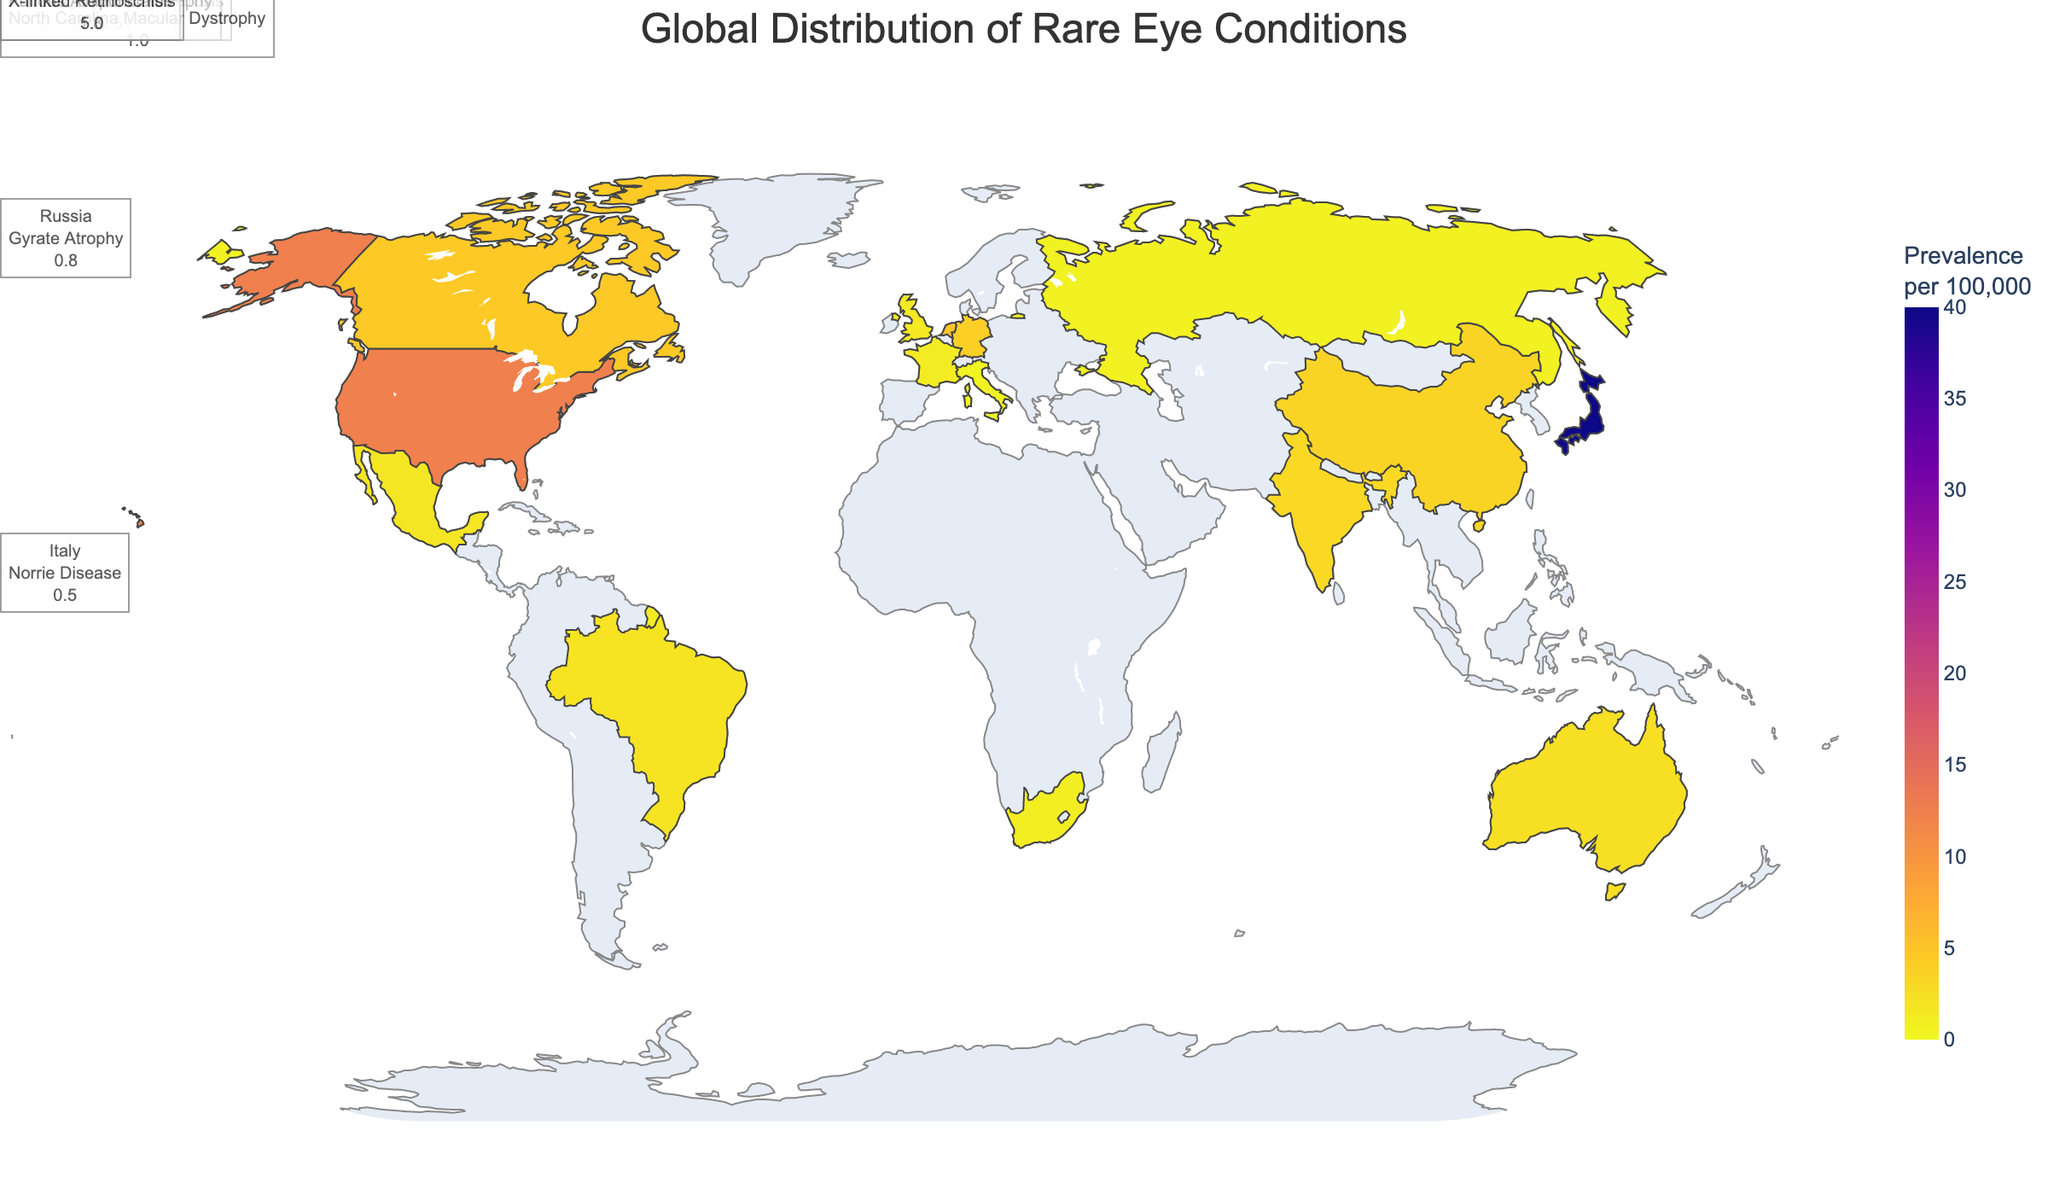What's the title of the figure? The title is usually found at the top of the figure. In this figure, it is "Global Distribution of Rare Eye Conditions".
Answer: Global Distribution of Rare Eye Conditions What's the prevalence rate of Retinitis Pigmentosa in Japan? The prevalence rate can be seen when you hover over Japan. It shows Retinitis Pigmentosa with a prevalence rate of 40.0 per 100,000.
Answer: 40.0 per 100,000 What condition is most prevalent in the United States and what is its prevalence rate? By looking at the hover data for the United States, it is clear that the condition is Stargardt Disease with a prevalence of 12.5 per 100,000.
Answer: Stargardt Disease, 12.5 per 100,000 How does the prevalence rate of Usher Syndrome in Germany compare to Fundus Albipunctatus in Mexico? By hovering over Germany, you can see that Usher Syndrome has a prevalence rate of 4.0 per 100,000. In Mexico, Fundus Albipunctatus has a prevalence rate of 1.8 per 100,000. Therefore, Usher Syndrome in Germany has a higher prevalence rate.
Answer: Higher in Germany What is the average prevalence rate of all the conditions listed? Sum all prevalence rates and divide by the number of countries (15 total): (12.5 + 40.0 + 4.0 + 2.0 + 3.0 + 1.5 + 2.5 + 4.5 + 1.2 + 3.5 + 0.5 + 1.0 + 0.8 + 1.8 + 5.0) = 83.8; then divide by 15 to get the average which is approximately 5.59.
Answer: 5.59 per 100,000 Which country has the lowest prevalence rate of the conditions listed, and what is the condition? By comparing all the prevalence rates, Italy has the lowest with Norrie Disease at 0.5 per 100,000.
Answer: Italy, Norrie Disease Which country has the highest prevalence rate, and for which condition? By comparing all the values, Japan has the highest prevalence rate for Retinitis Pigmentosa at 40.0 per 100,000.
Answer: Japan, Retinitis Pigmentosa What's the combined prevalence rate of conditions in Brazil and India? Add the prevalence rates for Brazil (2.0 for Leber Congenital Amaurosis) and India (3.0 for Achromatopsia): 2.0 + 3.0 = 5.0 per 100,000.
Answer: 5.0 per 100,000 